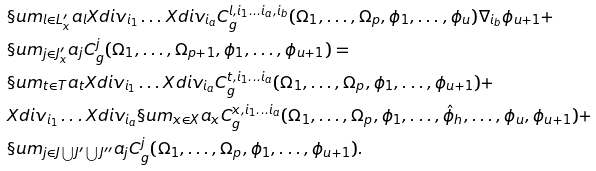<formula> <loc_0><loc_0><loc_500><loc_500>& \S u m _ { l \in L ^ { \prime } _ { x } } a _ { l } X d i v _ { i _ { 1 } } \dots X d i v _ { i _ { a } } C ^ { l , i _ { 1 } \dots i _ { a } , i _ { b } } _ { g } ( \Omega _ { 1 } , \dots , \Omega _ { p } , \phi _ { 1 } , \dots , \phi _ { u } ) \nabla _ { i _ { b } } \phi _ { u + 1 } + \\ & \S u m _ { j \in J ^ { \prime } _ { x } } a _ { j } C ^ { j } _ { g } ( \Omega _ { 1 } , \dots , \Omega _ { p + 1 } , \phi _ { 1 } , \dots , \phi _ { u + 1 } ) = \\ & \S u m _ { t \in T } a _ { t } X d i v _ { i _ { 1 } } \dots X d i v _ { i _ { a } } C ^ { t , i _ { 1 } \dots i _ { a } } _ { g } ( \Omega _ { 1 } , \dots , \Omega _ { p } , \phi _ { 1 } , \dots , \phi _ { u + 1 } ) + \\ & X d i v _ { i _ { 1 } } \dots X d i v _ { i _ { a } } \S u m _ { x \in X } a _ { x } C ^ { x , i _ { 1 } \dots i _ { a } } _ { g } ( \Omega _ { 1 } , \dots , \Omega _ { p } , \phi _ { 1 } , \dots , \hat { \phi } _ { h } , \dots , \phi _ { u } , \phi _ { u + 1 } ) + \\ & \S u m _ { j \in J \bigcup J ^ { \prime } \bigcup J ^ { \prime \prime } } a _ { j } C ^ { j } _ { g } ( \Omega _ { 1 } , \dots , \Omega _ { p } , \phi _ { 1 } , \dots , \phi _ { u + 1 } ) .</formula> 